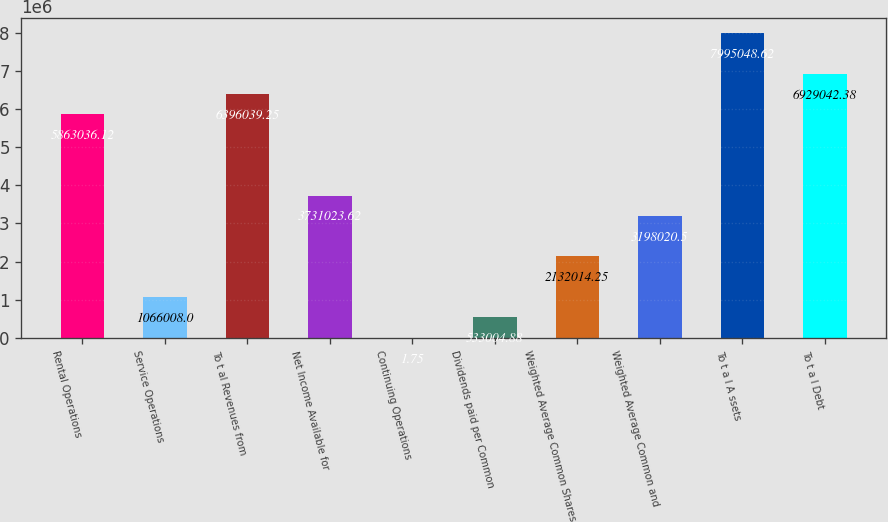Convert chart to OTSL. <chart><loc_0><loc_0><loc_500><loc_500><bar_chart><fcel>Rental Operations<fcel>Service Operations<fcel>To t al Revenues from<fcel>Net Income Available for<fcel>Continuing Operations<fcel>Dividends paid per Common<fcel>Weighted Average Common Shares<fcel>Weighted Average Common and<fcel>To t a l A ssets<fcel>To t a l Debt<nl><fcel>5.86304e+06<fcel>1.06601e+06<fcel>6.39604e+06<fcel>3.73102e+06<fcel>1.75<fcel>533005<fcel>2.13201e+06<fcel>3.19802e+06<fcel>7.99505e+06<fcel>6.92904e+06<nl></chart> 